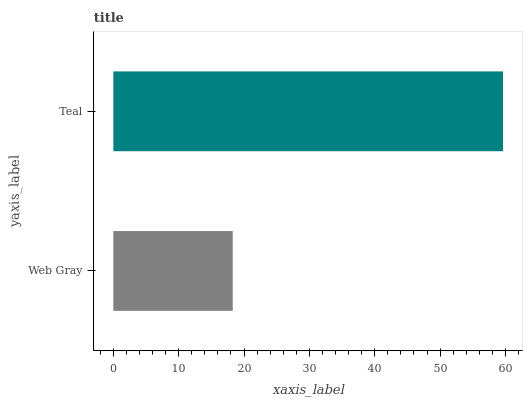Is Web Gray the minimum?
Answer yes or no. Yes. Is Teal the maximum?
Answer yes or no. Yes. Is Teal the minimum?
Answer yes or no. No. Is Teal greater than Web Gray?
Answer yes or no. Yes. Is Web Gray less than Teal?
Answer yes or no. Yes. Is Web Gray greater than Teal?
Answer yes or no. No. Is Teal less than Web Gray?
Answer yes or no. No. Is Teal the high median?
Answer yes or no. Yes. Is Web Gray the low median?
Answer yes or no. Yes. Is Web Gray the high median?
Answer yes or no. No. Is Teal the low median?
Answer yes or no. No. 